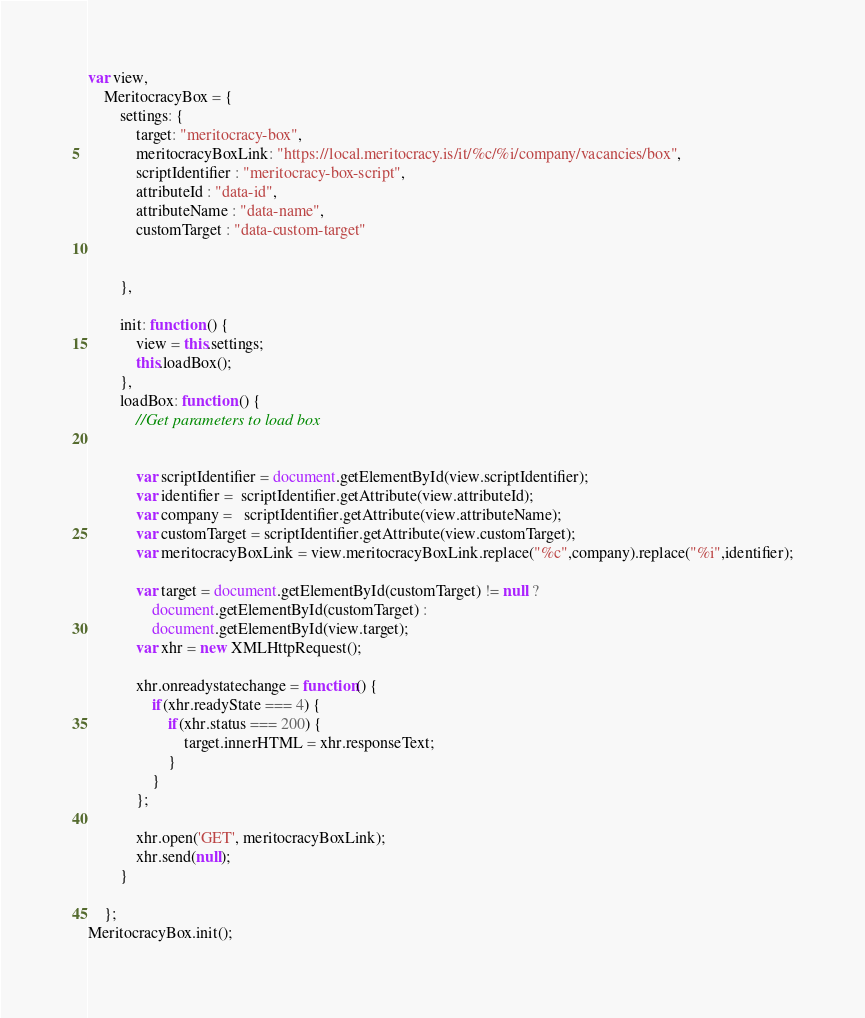<code> <loc_0><loc_0><loc_500><loc_500><_JavaScript_>var view,
    MeritocracyBox = {
        settings: {
            target: "meritocracy-box",
            meritocracyBoxLink: "https://local.meritocracy.is/it/%c/%i/company/vacancies/box",
            scriptIdentifier : "meritocracy-box-script",
            attributeId : "data-id",
            attributeName : "data-name",
            customTarget : "data-custom-target"


        },

        init: function () {
            view = this.settings;
            this.loadBox();
        },
        loadBox: function () {
            //Get parameters to load box


            var scriptIdentifier = document.getElementById(view.scriptIdentifier);
            var identifier =  scriptIdentifier.getAttribute(view.attributeId);
            var company =   scriptIdentifier.getAttribute(view.attributeName);
            var customTarget = scriptIdentifier.getAttribute(view.customTarget);
            var meritocracyBoxLink = view.meritocracyBoxLink.replace("%c",company).replace("%i",identifier);

            var target = document.getElementById(customTarget) != null ?
                document.getElementById(customTarget) :
                document.getElementById(view.target);
            var xhr = new XMLHttpRequest();

            xhr.onreadystatechange = function() {
                if(xhr.readyState === 4) {
                    if(xhr.status === 200) {
                        target.innerHTML = xhr.responseText;
                    }
                }
            };

            xhr.open('GET', meritocracyBoxLink);
            xhr.send(null);
        }

    };
MeritocracyBox.init();</code> 